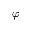<formula> <loc_0><loc_0><loc_500><loc_500>\varphi</formula> 